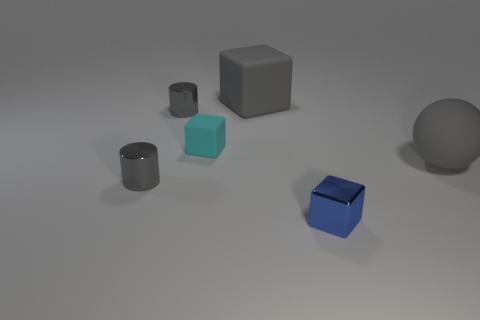Add 2 green cylinders. How many objects exist? 8 Subtract all cylinders. How many objects are left? 4 Add 5 blue metal blocks. How many blue metal blocks exist? 6 Subtract 0 green cylinders. How many objects are left? 6 Subtract all purple rubber cubes. Subtract all cyan objects. How many objects are left? 5 Add 5 metallic things. How many metallic things are left? 8 